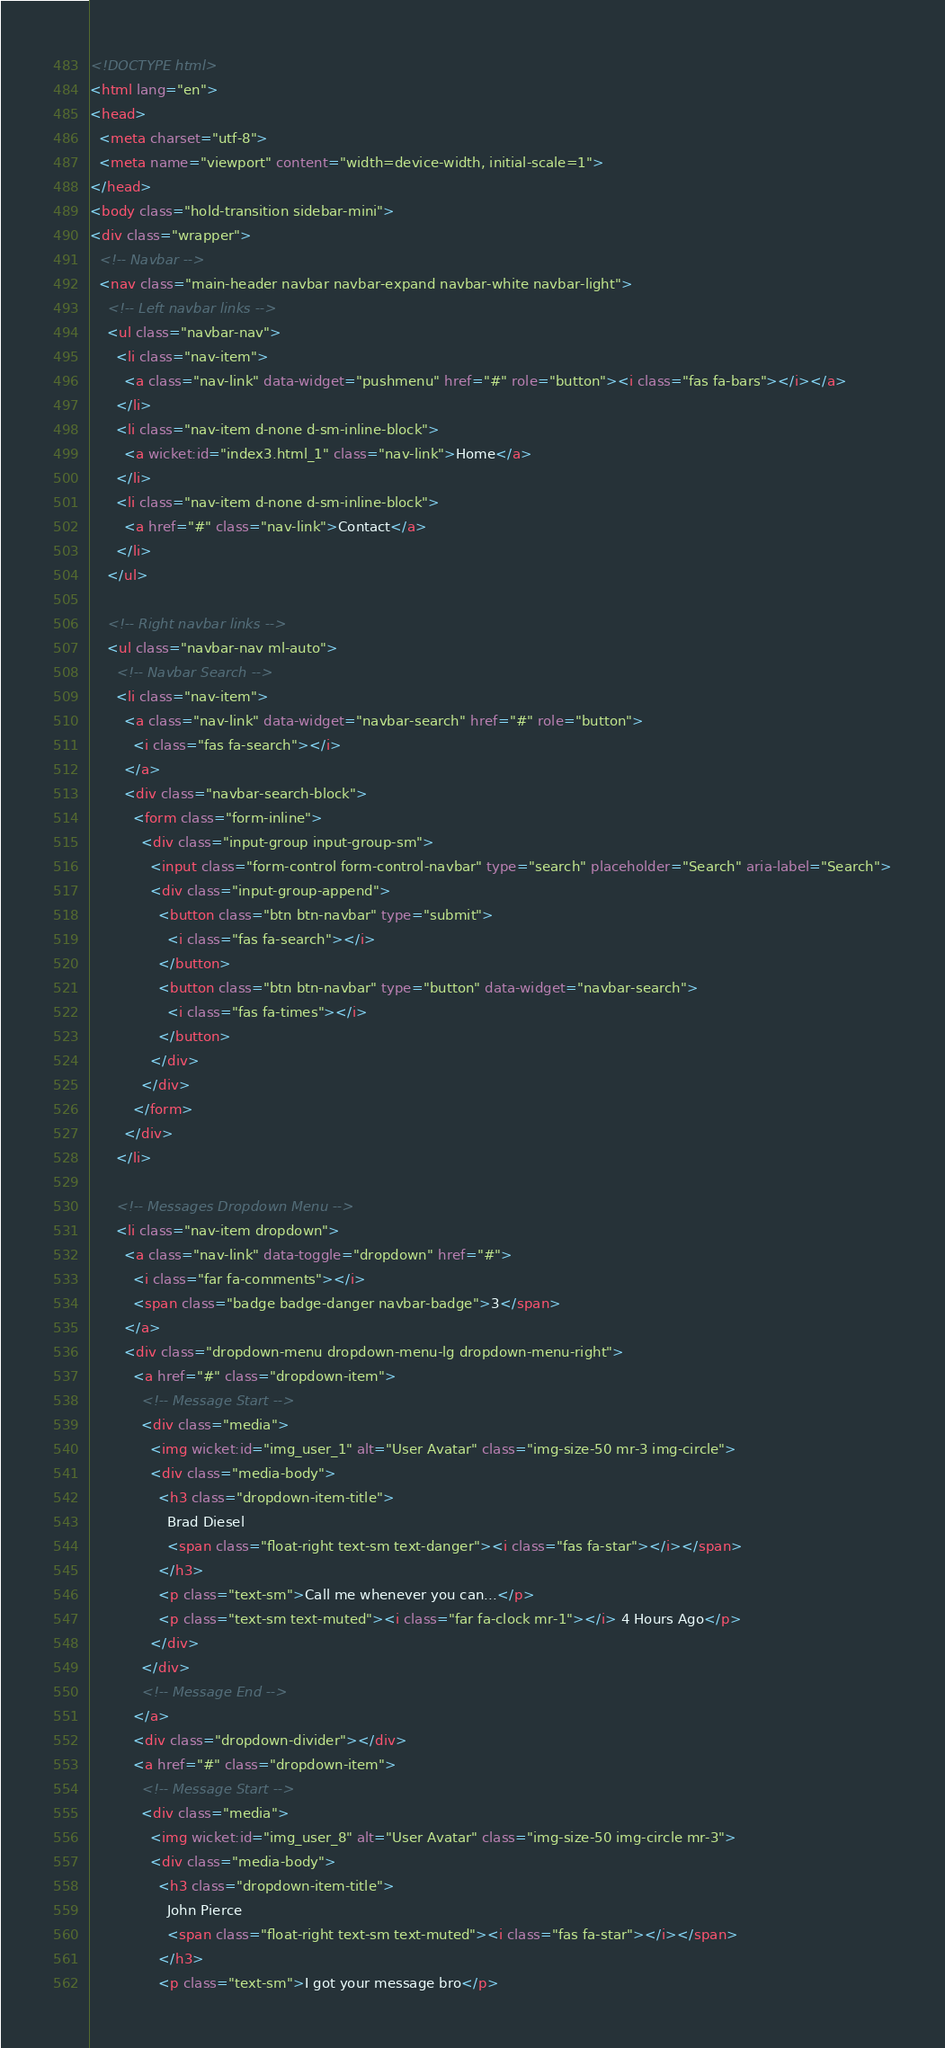Convert code to text. <code><loc_0><loc_0><loc_500><loc_500><_HTML_><!DOCTYPE html>
<html lang="en">
<head>
  <meta charset="utf-8">
  <meta name="viewport" content="width=device-width, initial-scale=1">
</head>
<body class="hold-transition sidebar-mini">
<div class="wrapper">
  <!-- Navbar -->
  <nav class="main-header navbar navbar-expand navbar-white navbar-light">
    <!-- Left navbar links -->
    <ul class="navbar-nav">
      <li class="nav-item">
        <a class="nav-link" data-widget="pushmenu" href="#" role="button"><i class="fas fa-bars"></i></a>
      </li>
      <li class="nav-item d-none d-sm-inline-block">
        <a wicket:id="index3.html_1" class="nav-link">Home</a>
      </li>
      <li class="nav-item d-none d-sm-inline-block">
        <a href="#" class="nav-link">Contact</a>
      </li>
    </ul>

    <!-- Right navbar links -->
    <ul class="navbar-nav ml-auto">
      <!-- Navbar Search -->
      <li class="nav-item">
        <a class="nav-link" data-widget="navbar-search" href="#" role="button">
          <i class="fas fa-search"></i>
        </a>
        <div class="navbar-search-block">
          <form class="form-inline">
            <div class="input-group input-group-sm">
              <input class="form-control form-control-navbar" type="search" placeholder="Search" aria-label="Search">
              <div class="input-group-append">
                <button class="btn btn-navbar" type="submit">
                  <i class="fas fa-search"></i>
                </button>
                <button class="btn btn-navbar" type="button" data-widget="navbar-search">
                  <i class="fas fa-times"></i>
                </button>
              </div>
            </div>
          </form>
        </div>
      </li>

      <!-- Messages Dropdown Menu -->
      <li class="nav-item dropdown">
        <a class="nav-link" data-toggle="dropdown" href="#">
          <i class="far fa-comments"></i>
          <span class="badge badge-danger navbar-badge">3</span>
        </a>
        <div class="dropdown-menu dropdown-menu-lg dropdown-menu-right">
          <a href="#" class="dropdown-item">
            <!-- Message Start -->
            <div class="media">
              <img wicket:id="img_user_1" alt="User Avatar" class="img-size-50 mr-3 img-circle">
              <div class="media-body">
                <h3 class="dropdown-item-title">
                  Brad Diesel
                  <span class="float-right text-sm text-danger"><i class="fas fa-star"></i></span>
                </h3>
                <p class="text-sm">Call me whenever you can...</p>
                <p class="text-sm text-muted"><i class="far fa-clock mr-1"></i> 4 Hours Ago</p>
              </div>
            </div>
            <!-- Message End -->
          </a>
          <div class="dropdown-divider"></div>
          <a href="#" class="dropdown-item">
            <!-- Message Start -->
            <div class="media">
              <img wicket:id="img_user_8" alt="User Avatar" class="img-size-50 img-circle mr-3">
              <div class="media-body">
                <h3 class="dropdown-item-title">
                  John Pierce
                  <span class="float-right text-sm text-muted"><i class="fas fa-star"></i></span>
                </h3>
                <p class="text-sm">I got your message bro</p></code> 